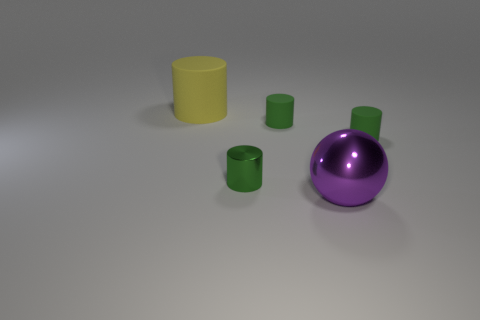Can you tell me what colors are present in the objects in the image? Certainly! The image features objects in shades of cyan, yellow, and purple. 